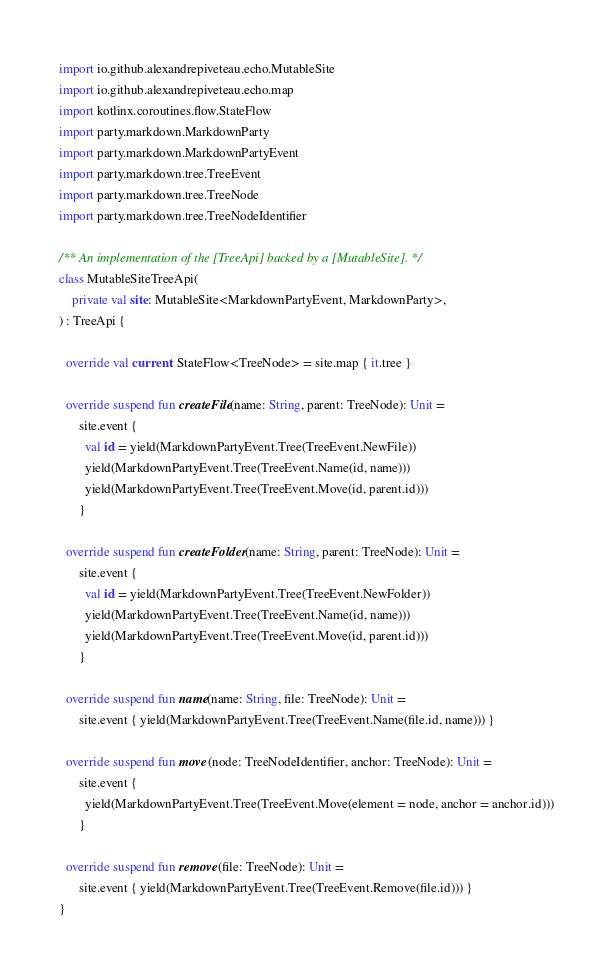<code> <loc_0><loc_0><loc_500><loc_500><_Kotlin_>
import io.github.alexandrepiveteau.echo.MutableSite
import io.github.alexandrepiveteau.echo.map
import kotlinx.coroutines.flow.StateFlow
import party.markdown.MarkdownParty
import party.markdown.MarkdownPartyEvent
import party.markdown.tree.TreeEvent
import party.markdown.tree.TreeNode
import party.markdown.tree.TreeNodeIdentifier

/** An implementation of the [TreeApi] backed by a [MutableSite]. */
class MutableSiteTreeApi(
    private val site: MutableSite<MarkdownPartyEvent, MarkdownParty>,
) : TreeApi {

  override val current: StateFlow<TreeNode> = site.map { it.tree }

  override suspend fun createFile(name: String, parent: TreeNode): Unit =
      site.event {
        val id = yield(MarkdownPartyEvent.Tree(TreeEvent.NewFile))
        yield(MarkdownPartyEvent.Tree(TreeEvent.Name(id, name)))
        yield(MarkdownPartyEvent.Tree(TreeEvent.Move(id, parent.id)))
      }

  override suspend fun createFolder(name: String, parent: TreeNode): Unit =
      site.event {
        val id = yield(MarkdownPartyEvent.Tree(TreeEvent.NewFolder))
        yield(MarkdownPartyEvent.Tree(TreeEvent.Name(id, name)))
        yield(MarkdownPartyEvent.Tree(TreeEvent.Move(id, parent.id)))
      }

  override suspend fun name(name: String, file: TreeNode): Unit =
      site.event { yield(MarkdownPartyEvent.Tree(TreeEvent.Name(file.id, name))) }

  override suspend fun move(node: TreeNodeIdentifier, anchor: TreeNode): Unit =
      site.event {
        yield(MarkdownPartyEvent.Tree(TreeEvent.Move(element = node, anchor = anchor.id)))
      }

  override suspend fun remove(file: TreeNode): Unit =
      site.event { yield(MarkdownPartyEvent.Tree(TreeEvent.Remove(file.id))) }
}
</code> 